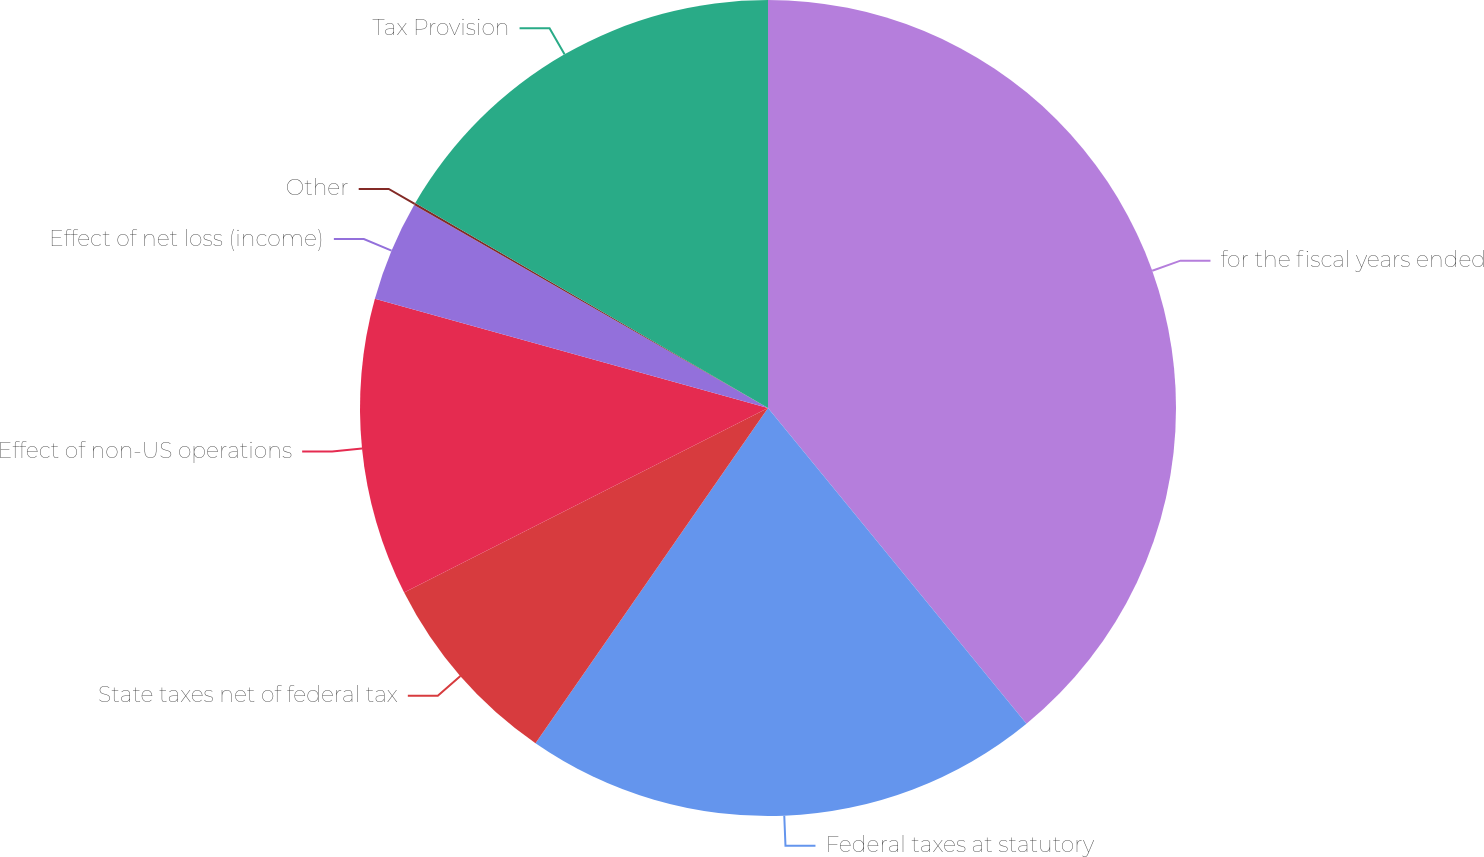Convert chart. <chart><loc_0><loc_0><loc_500><loc_500><pie_chart><fcel>for the fiscal years ended<fcel>Federal taxes at statutory<fcel>State taxes net of federal tax<fcel>Effect of non-US operations<fcel>Effect of net loss (income)<fcel>Other<fcel>Tax Provision<nl><fcel>39.08%<fcel>20.57%<fcel>7.88%<fcel>11.78%<fcel>3.98%<fcel>0.09%<fcel>16.62%<nl></chart> 